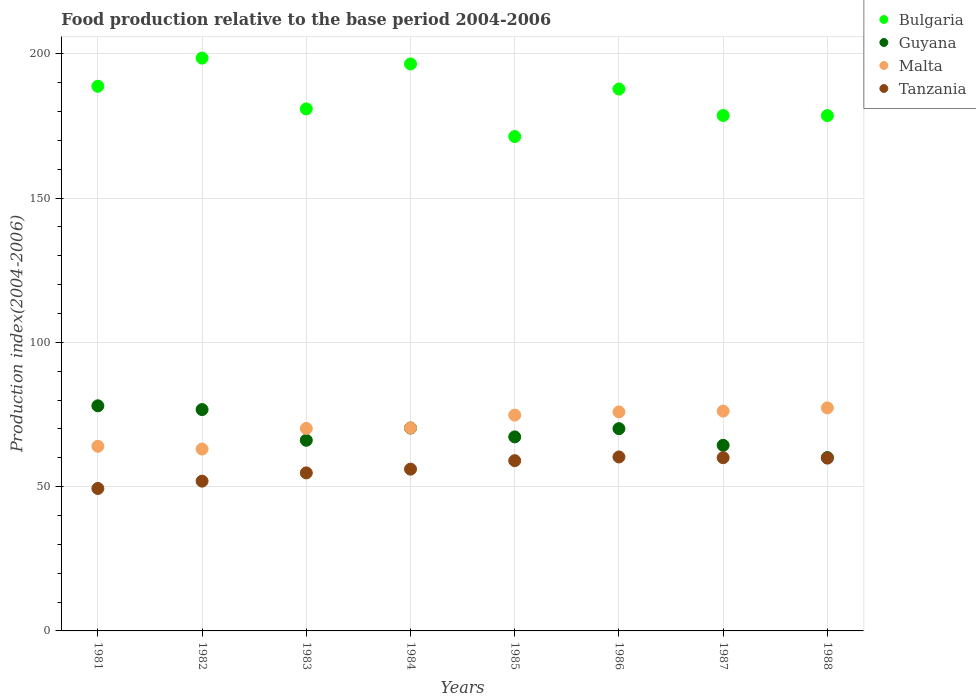How many different coloured dotlines are there?
Make the answer very short. 4. Is the number of dotlines equal to the number of legend labels?
Provide a short and direct response. Yes. What is the food production index in Malta in 1983?
Make the answer very short. 70.17. Across all years, what is the maximum food production index in Guyana?
Keep it short and to the point. 78.02. Across all years, what is the minimum food production index in Guyana?
Give a very brief answer. 60.08. What is the total food production index in Bulgaria in the graph?
Provide a succinct answer. 1481.03. What is the difference between the food production index in Malta in 1981 and that in 1987?
Your response must be concise. -12.19. What is the difference between the food production index in Guyana in 1981 and the food production index in Malta in 1987?
Ensure brevity in your answer.  1.84. What is the average food production index in Guyana per year?
Your answer should be compact. 69.11. In the year 1982, what is the difference between the food production index in Tanzania and food production index in Bulgaria?
Provide a short and direct response. -146.61. What is the ratio of the food production index in Guyana in 1984 to that in 1988?
Make the answer very short. 1.17. Is the difference between the food production index in Tanzania in 1981 and 1982 greater than the difference between the food production index in Bulgaria in 1981 and 1982?
Provide a short and direct response. Yes. What is the difference between the highest and the second highest food production index in Tanzania?
Your answer should be very brief. 0.26. What is the difference between the highest and the lowest food production index in Bulgaria?
Offer a very short reply. 27.19. Is the sum of the food production index in Malta in 1982 and 1986 greater than the maximum food production index in Guyana across all years?
Ensure brevity in your answer.  Yes. Is it the case that in every year, the sum of the food production index in Tanzania and food production index in Malta  is greater than the food production index in Bulgaria?
Give a very brief answer. No. Does the food production index in Bulgaria monotonically increase over the years?
Offer a terse response. No. Is the food production index in Bulgaria strictly greater than the food production index in Guyana over the years?
Provide a succinct answer. Yes. Is the food production index in Guyana strictly less than the food production index in Bulgaria over the years?
Provide a succinct answer. Yes. How many dotlines are there?
Your answer should be compact. 4. How many years are there in the graph?
Keep it short and to the point. 8. Are the values on the major ticks of Y-axis written in scientific E-notation?
Your response must be concise. No. Does the graph contain grids?
Offer a terse response. Yes. Where does the legend appear in the graph?
Give a very brief answer. Top right. What is the title of the graph?
Offer a terse response. Food production relative to the base period 2004-2006. Does "Tunisia" appear as one of the legend labels in the graph?
Provide a succinct answer. No. What is the label or title of the X-axis?
Offer a terse response. Years. What is the label or title of the Y-axis?
Provide a short and direct response. Production index(2004-2006). What is the Production index(2004-2006) of Bulgaria in 1981?
Provide a short and direct response. 188.76. What is the Production index(2004-2006) of Guyana in 1981?
Your answer should be compact. 78.02. What is the Production index(2004-2006) in Malta in 1981?
Offer a very short reply. 63.99. What is the Production index(2004-2006) of Tanzania in 1981?
Your answer should be compact. 49.37. What is the Production index(2004-2006) of Bulgaria in 1982?
Offer a terse response. 198.52. What is the Production index(2004-2006) of Guyana in 1982?
Your response must be concise. 76.71. What is the Production index(2004-2006) in Malta in 1982?
Your answer should be very brief. 63.03. What is the Production index(2004-2006) of Tanzania in 1982?
Offer a terse response. 51.91. What is the Production index(2004-2006) in Bulgaria in 1983?
Your answer should be very brief. 180.91. What is the Production index(2004-2006) in Guyana in 1983?
Make the answer very short. 66.07. What is the Production index(2004-2006) of Malta in 1983?
Your answer should be very brief. 70.17. What is the Production index(2004-2006) in Tanzania in 1983?
Your answer should be very brief. 54.77. What is the Production index(2004-2006) of Bulgaria in 1984?
Offer a terse response. 196.49. What is the Production index(2004-2006) in Guyana in 1984?
Offer a terse response. 70.31. What is the Production index(2004-2006) in Malta in 1984?
Provide a succinct answer. 70.35. What is the Production index(2004-2006) of Tanzania in 1984?
Your answer should be very brief. 56.07. What is the Production index(2004-2006) of Bulgaria in 1985?
Your answer should be compact. 171.33. What is the Production index(2004-2006) in Guyana in 1985?
Give a very brief answer. 67.24. What is the Production index(2004-2006) of Malta in 1985?
Offer a terse response. 74.79. What is the Production index(2004-2006) of Tanzania in 1985?
Your response must be concise. 59.01. What is the Production index(2004-2006) in Bulgaria in 1986?
Make the answer very short. 187.8. What is the Production index(2004-2006) in Guyana in 1986?
Your answer should be very brief. 70.1. What is the Production index(2004-2006) of Malta in 1986?
Provide a succinct answer. 75.89. What is the Production index(2004-2006) of Tanzania in 1986?
Ensure brevity in your answer.  60.29. What is the Production index(2004-2006) in Bulgaria in 1987?
Give a very brief answer. 178.63. What is the Production index(2004-2006) of Guyana in 1987?
Offer a terse response. 64.32. What is the Production index(2004-2006) in Malta in 1987?
Ensure brevity in your answer.  76.18. What is the Production index(2004-2006) of Tanzania in 1987?
Your answer should be compact. 60.03. What is the Production index(2004-2006) in Bulgaria in 1988?
Ensure brevity in your answer.  178.59. What is the Production index(2004-2006) of Guyana in 1988?
Offer a terse response. 60.08. What is the Production index(2004-2006) in Malta in 1988?
Keep it short and to the point. 77.3. What is the Production index(2004-2006) of Tanzania in 1988?
Give a very brief answer. 59.89. Across all years, what is the maximum Production index(2004-2006) in Bulgaria?
Your response must be concise. 198.52. Across all years, what is the maximum Production index(2004-2006) in Guyana?
Your response must be concise. 78.02. Across all years, what is the maximum Production index(2004-2006) in Malta?
Your answer should be compact. 77.3. Across all years, what is the maximum Production index(2004-2006) of Tanzania?
Give a very brief answer. 60.29. Across all years, what is the minimum Production index(2004-2006) in Bulgaria?
Provide a short and direct response. 171.33. Across all years, what is the minimum Production index(2004-2006) in Guyana?
Give a very brief answer. 60.08. Across all years, what is the minimum Production index(2004-2006) in Malta?
Give a very brief answer. 63.03. Across all years, what is the minimum Production index(2004-2006) in Tanzania?
Make the answer very short. 49.37. What is the total Production index(2004-2006) of Bulgaria in the graph?
Offer a very short reply. 1481.03. What is the total Production index(2004-2006) in Guyana in the graph?
Provide a short and direct response. 552.85. What is the total Production index(2004-2006) in Malta in the graph?
Provide a short and direct response. 571.7. What is the total Production index(2004-2006) of Tanzania in the graph?
Make the answer very short. 451.34. What is the difference between the Production index(2004-2006) of Bulgaria in 1981 and that in 1982?
Your answer should be compact. -9.76. What is the difference between the Production index(2004-2006) in Guyana in 1981 and that in 1982?
Your response must be concise. 1.31. What is the difference between the Production index(2004-2006) of Malta in 1981 and that in 1982?
Your answer should be very brief. 0.96. What is the difference between the Production index(2004-2006) in Tanzania in 1981 and that in 1982?
Keep it short and to the point. -2.54. What is the difference between the Production index(2004-2006) in Bulgaria in 1981 and that in 1983?
Give a very brief answer. 7.85. What is the difference between the Production index(2004-2006) of Guyana in 1981 and that in 1983?
Your response must be concise. 11.95. What is the difference between the Production index(2004-2006) of Malta in 1981 and that in 1983?
Make the answer very short. -6.18. What is the difference between the Production index(2004-2006) in Tanzania in 1981 and that in 1983?
Ensure brevity in your answer.  -5.4. What is the difference between the Production index(2004-2006) of Bulgaria in 1981 and that in 1984?
Provide a succinct answer. -7.73. What is the difference between the Production index(2004-2006) of Guyana in 1981 and that in 1984?
Give a very brief answer. 7.71. What is the difference between the Production index(2004-2006) in Malta in 1981 and that in 1984?
Your answer should be compact. -6.36. What is the difference between the Production index(2004-2006) in Bulgaria in 1981 and that in 1985?
Provide a succinct answer. 17.43. What is the difference between the Production index(2004-2006) in Guyana in 1981 and that in 1985?
Make the answer very short. 10.78. What is the difference between the Production index(2004-2006) in Malta in 1981 and that in 1985?
Offer a terse response. -10.8. What is the difference between the Production index(2004-2006) in Tanzania in 1981 and that in 1985?
Your response must be concise. -9.64. What is the difference between the Production index(2004-2006) in Bulgaria in 1981 and that in 1986?
Provide a short and direct response. 0.96. What is the difference between the Production index(2004-2006) in Guyana in 1981 and that in 1986?
Give a very brief answer. 7.92. What is the difference between the Production index(2004-2006) of Malta in 1981 and that in 1986?
Ensure brevity in your answer.  -11.9. What is the difference between the Production index(2004-2006) of Tanzania in 1981 and that in 1986?
Your answer should be very brief. -10.92. What is the difference between the Production index(2004-2006) in Bulgaria in 1981 and that in 1987?
Ensure brevity in your answer.  10.13. What is the difference between the Production index(2004-2006) in Guyana in 1981 and that in 1987?
Ensure brevity in your answer.  13.7. What is the difference between the Production index(2004-2006) of Malta in 1981 and that in 1987?
Your response must be concise. -12.19. What is the difference between the Production index(2004-2006) in Tanzania in 1981 and that in 1987?
Your answer should be compact. -10.66. What is the difference between the Production index(2004-2006) in Bulgaria in 1981 and that in 1988?
Offer a very short reply. 10.17. What is the difference between the Production index(2004-2006) in Guyana in 1981 and that in 1988?
Provide a succinct answer. 17.94. What is the difference between the Production index(2004-2006) of Malta in 1981 and that in 1988?
Your response must be concise. -13.31. What is the difference between the Production index(2004-2006) of Tanzania in 1981 and that in 1988?
Your answer should be very brief. -10.52. What is the difference between the Production index(2004-2006) in Bulgaria in 1982 and that in 1983?
Keep it short and to the point. 17.61. What is the difference between the Production index(2004-2006) in Guyana in 1982 and that in 1983?
Give a very brief answer. 10.64. What is the difference between the Production index(2004-2006) of Malta in 1982 and that in 1983?
Ensure brevity in your answer.  -7.14. What is the difference between the Production index(2004-2006) of Tanzania in 1982 and that in 1983?
Offer a very short reply. -2.86. What is the difference between the Production index(2004-2006) of Bulgaria in 1982 and that in 1984?
Make the answer very short. 2.03. What is the difference between the Production index(2004-2006) of Malta in 1982 and that in 1984?
Keep it short and to the point. -7.32. What is the difference between the Production index(2004-2006) of Tanzania in 1982 and that in 1984?
Ensure brevity in your answer.  -4.16. What is the difference between the Production index(2004-2006) in Bulgaria in 1982 and that in 1985?
Keep it short and to the point. 27.19. What is the difference between the Production index(2004-2006) of Guyana in 1982 and that in 1985?
Offer a very short reply. 9.47. What is the difference between the Production index(2004-2006) of Malta in 1982 and that in 1985?
Give a very brief answer. -11.76. What is the difference between the Production index(2004-2006) of Bulgaria in 1982 and that in 1986?
Provide a short and direct response. 10.72. What is the difference between the Production index(2004-2006) in Guyana in 1982 and that in 1986?
Give a very brief answer. 6.61. What is the difference between the Production index(2004-2006) in Malta in 1982 and that in 1986?
Provide a succinct answer. -12.86. What is the difference between the Production index(2004-2006) of Tanzania in 1982 and that in 1986?
Offer a terse response. -8.38. What is the difference between the Production index(2004-2006) of Bulgaria in 1982 and that in 1987?
Provide a short and direct response. 19.89. What is the difference between the Production index(2004-2006) of Guyana in 1982 and that in 1987?
Ensure brevity in your answer.  12.39. What is the difference between the Production index(2004-2006) in Malta in 1982 and that in 1987?
Offer a very short reply. -13.15. What is the difference between the Production index(2004-2006) in Tanzania in 1982 and that in 1987?
Provide a succinct answer. -8.12. What is the difference between the Production index(2004-2006) in Bulgaria in 1982 and that in 1988?
Ensure brevity in your answer.  19.93. What is the difference between the Production index(2004-2006) in Guyana in 1982 and that in 1988?
Offer a very short reply. 16.63. What is the difference between the Production index(2004-2006) of Malta in 1982 and that in 1988?
Provide a short and direct response. -14.27. What is the difference between the Production index(2004-2006) of Tanzania in 1982 and that in 1988?
Provide a succinct answer. -7.98. What is the difference between the Production index(2004-2006) of Bulgaria in 1983 and that in 1984?
Offer a terse response. -15.58. What is the difference between the Production index(2004-2006) in Guyana in 1983 and that in 1984?
Provide a short and direct response. -4.24. What is the difference between the Production index(2004-2006) of Malta in 1983 and that in 1984?
Keep it short and to the point. -0.18. What is the difference between the Production index(2004-2006) in Tanzania in 1983 and that in 1984?
Your answer should be very brief. -1.3. What is the difference between the Production index(2004-2006) of Bulgaria in 1983 and that in 1985?
Your answer should be compact. 9.58. What is the difference between the Production index(2004-2006) in Guyana in 1983 and that in 1985?
Your response must be concise. -1.17. What is the difference between the Production index(2004-2006) in Malta in 1983 and that in 1985?
Provide a succinct answer. -4.62. What is the difference between the Production index(2004-2006) in Tanzania in 1983 and that in 1985?
Your answer should be compact. -4.24. What is the difference between the Production index(2004-2006) of Bulgaria in 1983 and that in 1986?
Offer a terse response. -6.89. What is the difference between the Production index(2004-2006) of Guyana in 1983 and that in 1986?
Your answer should be very brief. -4.03. What is the difference between the Production index(2004-2006) of Malta in 1983 and that in 1986?
Provide a short and direct response. -5.72. What is the difference between the Production index(2004-2006) in Tanzania in 1983 and that in 1986?
Make the answer very short. -5.52. What is the difference between the Production index(2004-2006) in Bulgaria in 1983 and that in 1987?
Your answer should be compact. 2.28. What is the difference between the Production index(2004-2006) in Malta in 1983 and that in 1987?
Provide a short and direct response. -6.01. What is the difference between the Production index(2004-2006) of Tanzania in 1983 and that in 1987?
Give a very brief answer. -5.26. What is the difference between the Production index(2004-2006) in Bulgaria in 1983 and that in 1988?
Ensure brevity in your answer.  2.32. What is the difference between the Production index(2004-2006) in Guyana in 1983 and that in 1988?
Ensure brevity in your answer.  5.99. What is the difference between the Production index(2004-2006) of Malta in 1983 and that in 1988?
Offer a terse response. -7.13. What is the difference between the Production index(2004-2006) of Tanzania in 1983 and that in 1988?
Your answer should be compact. -5.12. What is the difference between the Production index(2004-2006) of Bulgaria in 1984 and that in 1985?
Ensure brevity in your answer.  25.16. What is the difference between the Production index(2004-2006) of Guyana in 1984 and that in 1985?
Your response must be concise. 3.07. What is the difference between the Production index(2004-2006) in Malta in 1984 and that in 1985?
Your answer should be compact. -4.44. What is the difference between the Production index(2004-2006) of Tanzania in 1984 and that in 1985?
Ensure brevity in your answer.  -2.94. What is the difference between the Production index(2004-2006) of Bulgaria in 1984 and that in 1986?
Ensure brevity in your answer.  8.69. What is the difference between the Production index(2004-2006) in Guyana in 1984 and that in 1986?
Provide a succinct answer. 0.21. What is the difference between the Production index(2004-2006) of Malta in 1984 and that in 1986?
Make the answer very short. -5.54. What is the difference between the Production index(2004-2006) in Tanzania in 1984 and that in 1986?
Provide a succinct answer. -4.22. What is the difference between the Production index(2004-2006) in Bulgaria in 1984 and that in 1987?
Make the answer very short. 17.86. What is the difference between the Production index(2004-2006) of Guyana in 1984 and that in 1987?
Make the answer very short. 5.99. What is the difference between the Production index(2004-2006) in Malta in 1984 and that in 1987?
Your answer should be very brief. -5.83. What is the difference between the Production index(2004-2006) in Tanzania in 1984 and that in 1987?
Provide a short and direct response. -3.96. What is the difference between the Production index(2004-2006) in Bulgaria in 1984 and that in 1988?
Offer a very short reply. 17.9. What is the difference between the Production index(2004-2006) of Guyana in 1984 and that in 1988?
Ensure brevity in your answer.  10.23. What is the difference between the Production index(2004-2006) of Malta in 1984 and that in 1988?
Ensure brevity in your answer.  -6.95. What is the difference between the Production index(2004-2006) in Tanzania in 1984 and that in 1988?
Offer a very short reply. -3.82. What is the difference between the Production index(2004-2006) of Bulgaria in 1985 and that in 1986?
Your response must be concise. -16.47. What is the difference between the Production index(2004-2006) in Guyana in 1985 and that in 1986?
Provide a short and direct response. -2.86. What is the difference between the Production index(2004-2006) in Malta in 1985 and that in 1986?
Offer a terse response. -1.1. What is the difference between the Production index(2004-2006) of Tanzania in 1985 and that in 1986?
Make the answer very short. -1.28. What is the difference between the Production index(2004-2006) of Bulgaria in 1985 and that in 1987?
Give a very brief answer. -7.3. What is the difference between the Production index(2004-2006) of Guyana in 1985 and that in 1987?
Your answer should be very brief. 2.92. What is the difference between the Production index(2004-2006) of Malta in 1985 and that in 1987?
Ensure brevity in your answer.  -1.39. What is the difference between the Production index(2004-2006) in Tanzania in 1985 and that in 1987?
Provide a succinct answer. -1.02. What is the difference between the Production index(2004-2006) in Bulgaria in 1985 and that in 1988?
Provide a succinct answer. -7.26. What is the difference between the Production index(2004-2006) in Guyana in 1985 and that in 1988?
Your answer should be very brief. 7.16. What is the difference between the Production index(2004-2006) of Malta in 1985 and that in 1988?
Provide a short and direct response. -2.51. What is the difference between the Production index(2004-2006) in Tanzania in 1985 and that in 1988?
Offer a very short reply. -0.88. What is the difference between the Production index(2004-2006) in Bulgaria in 1986 and that in 1987?
Your answer should be very brief. 9.17. What is the difference between the Production index(2004-2006) in Guyana in 1986 and that in 1987?
Provide a succinct answer. 5.78. What is the difference between the Production index(2004-2006) of Malta in 1986 and that in 1987?
Give a very brief answer. -0.29. What is the difference between the Production index(2004-2006) of Tanzania in 1986 and that in 1987?
Your answer should be compact. 0.26. What is the difference between the Production index(2004-2006) of Bulgaria in 1986 and that in 1988?
Make the answer very short. 9.21. What is the difference between the Production index(2004-2006) of Guyana in 1986 and that in 1988?
Your response must be concise. 10.02. What is the difference between the Production index(2004-2006) of Malta in 1986 and that in 1988?
Make the answer very short. -1.41. What is the difference between the Production index(2004-2006) of Guyana in 1987 and that in 1988?
Provide a short and direct response. 4.24. What is the difference between the Production index(2004-2006) in Malta in 1987 and that in 1988?
Offer a very short reply. -1.12. What is the difference between the Production index(2004-2006) in Tanzania in 1987 and that in 1988?
Offer a very short reply. 0.14. What is the difference between the Production index(2004-2006) in Bulgaria in 1981 and the Production index(2004-2006) in Guyana in 1982?
Make the answer very short. 112.05. What is the difference between the Production index(2004-2006) of Bulgaria in 1981 and the Production index(2004-2006) of Malta in 1982?
Keep it short and to the point. 125.73. What is the difference between the Production index(2004-2006) in Bulgaria in 1981 and the Production index(2004-2006) in Tanzania in 1982?
Offer a very short reply. 136.85. What is the difference between the Production index(2004-2006) of Guyana in 1981 and the Production index(2004-2006) of Malta in 1982?
Make the answer very short. 14.99. What is the difference between the Production index(2004-2006) in Guyana in 1981 and the Production index(2004-2006) in Tanzania in 1982?
Provide a succinct answer. 26.11. What is the difference between the Production index(2004-2006) in Malta in 1981 and the Production index(2004-2006) in Tanzania in 1982?
Provide a short and direct response. 12.08. What is the difference between the Production index(2004-2006) in Bulgaria in 1981 and the Production index(2004-2006) in Guyana in 1983?
Keep it short and to the point. 122.69. What is the difference between the Production index(2004-2006) in Bulgaria in 1981 and the Production index(2004-2006) in Malta in 1983?
Your answer should be very brief. 118.59. What is the difference between the Production index(2004-2006) of Bulgaria in 1981 and the Production index(2004-2006) of Tanzania in 1983?
Your answer should be very brief. 133.99. What is the difference between the Production index(2004-2006) of Guyana in 1981 and the Production index(2004-2006) of Malta in 1983?
Your answer should be very brief. 7.85. What is the difference between the Production index(2004-2006) in Guyana in 1981 and the Production index(2004-2006) in Tanzania in 1983?
Provide a short and direct response. 23.25. What is the difference between the Production index(2004-2006) in Malta in 1981 and the Production index(2004-2006) in Tanzania in 1983?
Make the answer very short. 9.22. What is the difference between the Production index(2004-2006) of Bulgaria in 1981 and the Production index(2004-2006) of Guyana in 1984?
Offer a terse response. 118.45. What is the difference between the Production index(2004-2006) in Bulgaria in 1981 and the Production index(2004-2006) in Malta in 1984?
Offer a terse response. 118.41. What is the difference between the Production index(2004-2006) of Bulgaria in 1981 and the Production index(2004-2006) of Tanzania in 1984?
Keep it short and to the point. 132.69. What is the difference between the Production index(2004-2006) of Guyana in 1981 and the Production index(2004-2006) of Malta in 1984?
Offer a terse response. 7.67. What is the difference between the Production index(2004-2006) of Guyana in 1981 and the Production index(2004-2006) of Tanzania in 1984?
Provide a short and direct response. 21.95. What is the difference between the Production index(2004-2006) of Malta in 1981 and the Production index(2004-2006) of Tanzania in 1984?
Make the answer very short. 7.92. What is the difference between the Production index(2004-2006) in Bulgaria in 1981 and the Production index(2004-2006) in Guyana in 1985?
Give a very brief answer. 121.52. What is the difference between the Production index(2004-2006) of Bulgaria in 1981 and the Production index(2004-2006) of Malta in 1985?
Provide a short and direct response. 113.97. What is the difference between the Production index(2004-2006) in Bulgaria in 1981 and the Production index(2004-2006) in Tanzania in 1985?
Ensure brevity in your answer.  129.75. What is the difference between the Production index(2004-2006) in Guyana in 1981 and the Production index(2004-2006) in Malta in 1985?
Provide a short and direct response. 3.23. What is the difference between the Production index(2004-2006) of Guyana in 1981 and the Production index(2004-2006) of Tanzania in 1985?
Your response must be concise. 19.01. What is the difference between the Production index(2004-2006) of Malta in 1981 and the Production index(2004-2006) of Tanzania in 1985?
Your response must be concise. 4.98. What is the difference between the Production index(2004-2006) in Bulgaria in 1981 and the Production index(2004-2006) in Guyana in 1986?
Ensure brevity in your answer.  118.66. What is the difference between the Production index(2004-2006) in Bulgaria in 1981 and the Production index(2004-2006) in Malta in 1986?
Offer a very short reply. 112.87. What is the difference between the Production index(2004-2006) of Bulgaria in 1981 and the Production index(2004-2006) of Tanzania in 1986?
Offer a terse response. 128.47. What is the difference between the Production index(2004-2006) in Guyana in 1981 and the Production index(2004-2006) in Malta in 1986?
Give a very brief answer. 2.13. What is the difference between the Production index(2004-2006) in Guyana in 1981 and the Production index(2004-2006) in Tanzania in 1986?
Make the answer very short. 17.73. What is the difference between the Production index(2004-2006) of Bulgaria in 1981 and the Production index(2004-2006) of Guyana in 1987?
Provide a short and direct response. 124.44. What is the difference between the Production index(2004-2006) of Bulgaria in 1981 and the Production index(2004-2006) of Malta in 1987?
Keep it short and to the point. 112.58. What is the difference between the Production index(2004-2006) in Bulgaria in 1981 and the Production index(2004-2006) in Tanzania in 1987?
Keep it short and to the point. 128.73. What is the difference between the Production index(2004-2006) in Guyana in 1981 and the Production index(2004-2006) in Malta in 1987?
Give a very brief answer. 1.84. What is the difference between the Production index(2004-2006) of Guyana in 1981 and the Production index(2004-2006) of Tanzania in 1987?
Your response must be concise. 17.99. What is the difference between the Production index(2004-2006) of Malta in 1981 and the Production index(2004-2006) of Tanzania in 1987?
Keep it short and to the point. 3.96. What is the difference between the Production index(2004-2006) of Bulgaria in 1981 and the Production index(2004-2006) of Guyana in 1988?
Provide a succinct answer. 128.68. What is the difference between the Production index(2004-2006) of Bulgaria in 1981 and the Production index(2004-2006) of Malta in 1988?
Provide a succinct answer. 111.46. What is the difference between the Production index(2004-2006) of Bulgaria in 1981 and the Production index(2004-2006) of Tanzania in 1988?
Your answer should be compact. 128.87. What is the difference between the Production index(2004-2006) in Guyana in 1981 and the Production index(2004-2006) in Malta in 1988?
Provide a short and direct response. 0.72. What is the difference between the Production index(2004-2006) in Guyana in 1981 and the Production index(2004-2006) in Tanzania in 1988?
Ensure brevity in your answer.  18.13. What is the difference between the Production index(2004-2006) of Malta in 1981 and the Production index(2004-2006) of Tanzania in 1988?
Your answer should be very brief. 4.1. What is the difference between the Production index(2004-2006) of Bulgaria in 1982 and the Production index(2004-2006) of Guyana in 1983?
Offer a very short reply. 132.45. What is the difference between the Production index(2004-2006) of Bulgaria in 1982 and the Production index(2004-2006) of Malta in 1983?
Offer a very short reply. 128.35. What is the difference between the Production index(2004-2006) of Bulgaria in 1982 and the Production index(2004-2006) of Tanzania in 1983?
Offer a terse response. 143.75. What is the difference between the Production index(2004-2006) in Guyana in 1982 and the Production index(2004-2006) in Malta in 1983?
Offer a terse response. 6.54. What is the difference between the Production index(2004-2006) in Guyana in 1982 and the Production index(2004-2006) in Tanzania in 1983?
Provide a short and direct response. 21.94. What is the difference between the Production index(2004-2006) in Malta in 1982 and the Production index(2004-2006) in Tanzania in 1983?
Offer a terse response. 8.26. What is the difference between the Production index(2004-2006) of Bulgaria in 1982 and the Production index(2004-2006) of Guyana in 1984?
Ensure brevity in your answer.  128.21. What is the difference between the Production index(2004-2006) in Bulgaria in 1982 and the Production index(2004-2006) in Malta in 1984?
Offer a terse response. 128.17. What is the difference between the Production index(2004-2006) in Bulgaria in 1982 and the Production index(2004-2006) in Tanzania in 1984?
Provide a short and direct response. 142.45. What is the difference between the Production index(2004-2006) of Guyana in 1982 and the Production index(2004-2006) of Malta in 1984?
Keep it short and to the point. 6.36. What is the difference between the Production index(2004-2006) in Guyana in 1982 and the Production index(2004-2006) in Tanzania in 1984?
Your answer should be compact. 20.64. What is the difference between the Production index(2004-2006) of Malta in 1982 and the Production index(2004-2006) of Tanzania in 1984?
Offer a very short reply. 6.96. What is the difference between the Production index(2004-2006) in Bulgaria in 1982 and the Production index(2004-2006) in Guyana in 1985?
Keep it short and to the point. 131.28. What is the difference between the Production index(2004-2006) in Bulgaria in 1982 and the Production index(2004-2006) in Malta in 1985?
Offer a very short reply. 123.73. What is the difference between the Production index(2004-2006) of Bulgaria in 1982 and the Production index(2004-2006) of Tanzania in 1985?
Your answer should be compact. 139.51. What is the difference between the Production index(2004-2006) in Guyana in 1982 and the Production index(2004-2006) in Malta in 1985?
Give a very brief answer. 1.92. What is the difference between the Production index(2004-2006) of Malta in 1982 and the Production index(2004-2006) of Tanzania in 1985?
Your response must be concise. 4.02. What is the difference between the Production index(2004-2006) of Bulgaria in 1982 and the Production index(2004-2006) of Guyana in 1986?
Make the answer very short. 128.42. What is the difference between the Production index(2004-2006) in Bulgaria in 1982 and the Production index(2004-2006) in Malta in 1986?
Your response must be concise. 122.63. What is the difference between the Production index(2004-2006) of Bulgaria in 1982 and the Production index(2004-2006) of Tanzania in 1986?
Your answer should be very brief. 138.23. What is the difference between the Production index(2004-2006) of Guyana in 1982 and the Production index(2004-2006) of Malta in 1986?
Your answer should be compact. 0.82. What is the difference between the Production index(2004-2006) of Guyana in 1982 and the Production index(2004-2006) of Tanzania in 1986?
Make the answer very short. 16.42. What is the difference between the Production index(2004-2006) in Malta in 1982 and the Production index(2004-2006) in Tanzania in 1986?
Make the answer very short. 2.74. What is the difference between the Production index(2004-2006) in Bulgaria in 1982 and the Production index(2004-2006) in Guyana in 1987?
Offer a terse response. 134.2. What is the difference between the Production index(2004-2006) of Bulgaria in 1982 and the Production index(2004-2006) of Malta in 1987?
Offer a very short reply. 122.34. What is the difference between the Production index(2004-2006) of Bulgaria in 1982 and the Production index(2004-2006) of Tanzania in 1987?
Keep it short and to the point. 138.49. What is the difference between the Production index(2004-2006) of Guyana in 1982 and the Production index(2004-2006) of Malta in 1987?
Provide a succinct answer. 0.53. What is the difference between the Production index(2004-2006) in Guyana in 1982 and the Production index(2004-2006) in Tanzania in 1987?
Keep it short and to the point. 16.68. What is the difference between the Production index(2004-2006) in Bulgaria in 1982 and the Production index(2004-2006) in Guyana in 1988?
Your answer should be very brief. 138.44. What is the difference between the Production index(2004-2006) in Bulgaria in 1982 and the Production index(2004-2006) in Malta in 1988?
Offer a very short reply. 121.22. What is the difference between the Production index(2004-2006) of Bulgaria in 1982 and the Production index(2004-2006) of Tanzania in 1988?
Your answer should be very brief. 138.63. What is the difference between the Production index(2004-2006) of Guyana in 1982 and the Production index(2004-2006) of Malta in 1988?
Give a very brief answer. -0.59. What is the difference between the Production index(2004-2006) of Guyana in 1982 and the Production index(2004-2006) of Tanzania in 1988?
Offer a terse response. 16.82. What is the difference between the Production index(2004-2006) in Malta in 1982 and the Production index(2004-2006) in Tanzania in 1988?
Give a very brief answer. 3.14. What is the difference between the Production index(2004-2006) in Bulgaria in 1983 and the Production index(2004-2006) in Guyana in 1984?
Offer a very short reply. 110.6. What is the difference between the Production index(2004-2006) in Bulgaria in 1983 and the Production index(2004-2006) in Malta in 1984?
Offer a very short reply. 110.56. What is the difference between the Production index(2004-2006) in Bulgaria in 1983 and the Production index(2004-2006) in Tanzania in 1984?
Offer a terse response. 124.84. What is the difference between the Production index(2004-2006) in Guyana in 1983 and the Production index(2004-2006) in Malta in 1984?
Your answer should be compact. -4.28. What is the difference between the Production index(2004-2006) of Guyana in 1983 and the Production index(2004-2006) of Tanzania in 1984?
Offer a terse response. 10. What is the difference between the Production index(2004-2006) in Bulgaria in 1983 and the Production index(2004-2006) in Guyana in 1985?
Provide a succinct answer. 113.67. What is the difference between the Production index(2004-2006) of Bulgaria in 1983 and the Production index(2004-2006) of Malta in 1985?
Ensure brevity in your answer.  106.12. What is the difference between the Production index(2004-2006) of Bulgaria in 1983 and the Production index(2004-2006) of Tanzania in 1985?
Provide a short and direct response. 121.9. What is the difference between the Production index(2004-2006) in Guyana in 1983 and the Production index(2004-2006) in Malta in 1985?
Make the answer very short. -8.72. What is the difference between the Production index(2004-2006) of Guyana in 1983 and the Production index(2004-2006) of Tanzania in 1985?
Give a very brief answer. 7.06. What is the difference between the Production index(2004-2006) of Malta in 1983 and the Production index(2004-2006) of Tanzania in 1985?
Give a very brief answer. 11.16. What is the difference between the Production index(2004-2006) of Bulgaria in 1983 and the Production index(2004-2006) of Guyana in 1986?
Your answer should be very brief. 110.81. What is the difference between the Production index(2004-2006) in Bulgaria in 1983 and the Production index(2004-2006) in Malta in 1986?
Provide a succinct answer. 105.02. What is the difference between the Production index(2004-2006) of Bulgaria in 1983 and the Production index(2004-2006) of Tanzania in 1986?
Your response must be concise. 120.62. What is the difference between the Production index(2004-2006) in Guyana in 1983 and the Production index(2004-2006) in Malta in 1986?
Provide a succinct answer. -9.82. What is the difference between the Production index(2004-2006) of Guyana in 1983 and the Production index(2004-2006) of Tanzania in 1986?
Your response must be concise. 5.78. What is the difference between the Production index(2004-2006) in Malta in 1983 and the Production index(2004-2006) in Tanzania in 1986?
Your response must be concise. 9.88. What is the difference between the Production index(2004-2006) of Bulgaria in 1983 and the Production index(2004-2006) of Guyana in 1987?
Your response must be concise. 116.59. What is the difference between the Production index(2004-2006) of Bulgaria in 1983 and the Production index(2004-2006) of Malta in 1987?
Offer a terse response. 104.73. What is the difference between the Production index(2004-2006) in Bulgaria in 1983 and the Production index(2004-2006) in Tanzania in 1987?
Ensure brevity in your answer.  120.88. What is the difference between the Production index(2004-2006) of Guyana in 1983 and the Production index(2004-2006) of Malta in 1987?
Offer a very short reply. -10.11. What is the difference between the Production index(2004-2006) of Guyana in 1983 and the Production index(2004-2006) of Tanzania in 1987?
Offer a terse response. 6.04. What is the difference between the Production index(2004-2006) in Malta in 1983 and the Production index(2004-2006) in Tanzania in 1987?
Offer a very short reply. 10.14. What is the difference between the Production index(2004-2006) of Bulgaria in 1983 and the Production index(2004-2006) of Guyana in 1988?
Your answer should be very brief. 120.83. What is the difference between the Production index(2004-2006) in Bulgaria in 1983 and the Production index(2004-2006) in Malta in 1988?
Make the answer very short. 103.61. What is the difference between the Production index(2004-2006) of Bulgaria in 1983 and the Production index(2004-2006) of Tanzania in 1988?
Offer a terse response. 121.02. What is the difference between the Production index(2004-2006) of Guyana in 1983 and the Production index(2004-2006) of Malta in 1988?
Offer a terse response. -11.23. What is the difference between the Production index(2004-2006) in Guyana in 1983 and the Production index(2004-2006) in Tanzania in 1988?
Your answer should be very brief. 6.18. What is the difference between the Production index(2004-2006) in Malta in 1983 and the Production index(2004-2006) in Tanzania in 1988?
Ensure brevity in your answer.  10.28. What is the difference between the Production index(2004-2006) of Bulgaria in 1984 and the Production index(2004-2006) of Guyana in 1985?
Your response must be concise. 129.25. What is the difference between the Production index(2004-2006) of Bulgaria in 1984 and the Production index(2004-2006) of Malta in 1985?
Give a very brief answer. 121.7. What is the difference between the Production index(2004-2006) of Bulgaria in 1984 and the Production index(2004-2006) of Tanzania in 1985?
Provide a succinct answer. 137.48. What is the difference between the Production index(2004-2006) in Guyana in 1984 and the Production index(2004-2006) in Malta in 1985?
Give a very brief answer. -4.48. What is the difference between the Production index(2004-2006) of Malta in 1984 and the Production index(2004-2006) of Tanzania in 1985?
Your answer should be compact. 11.34. What is the difference between the Production index(2004-2006) of Bulgaria in 1984 and the Production index(2004-2006) of Guyana in 1986?
Your answer should be very brief. 126.39. What is the difference between the Production index(2004-2006) of Bulgaria in 1984 and the Production index(2004-2006) of Malta in 1986?
Keep it short and to the point. 120.6. What is the difference between the Production index(2004-2006) in Bulgaria in 1984 and the Production index(2004-2006) in Tanzania in 1986?
Offer a terse response. 136.2. What is the difference between the Production index(2004-2006) of Guyana in 1984 and the Production index(2004-2006) of Malta in 1986?
Your response must be concise. -5.58. What is the difference between the Production index(2004-2006) in Guyana in 1984 and the Production index(2004-2006) in Tanzania in 1986?
Give a very brief answer. 10.02. What is the difference between the Production index(2004-2006) in Malta in 1984 and the Production index(2004-2006) in Tanzania in 1986?
Provide a succinct answer. 10.06. What is the difference between the Production index(2004-2006) in Bulgaria in 1984 and the Production index(2004-2006) in Guyana in 1987?
Give a very brief answer. 132.17. What is the difference between the Production index(2004-2006) in Bulgaria in 1984 and the Production index(2004-2006) in Malta in 1987?
Ensure brevity in your answer.  120.31. What is the difference between the Production index(2004-2006) of Bulgaria in 1984 and the Production index(2004-2006) of Tanzania in 1987?
Your answer should be very brief. 136.46. What is the difference between the Production index(2004-2006) in Guyana in 1984 and the Production index(2004-2006) in Malta in 1987?
Offer a terse response. -5.87. What is the difference between the Production index(2004-2006) of Guyana in 1984 and the Production index(2004-2006) of Tanzania in 1987?
Ensure brevity in your answer.  10.28. What is the difference between the Production index(2004-2006) of Malta in 1984 and the Production index(2004-2006) of Tanzania in 1987?
Give a very brief answer. 10.32. What is the difference between the Production index(2004-2006) in Bulgaria in 1984 and the Production index(2004-2006) in Guyana in 1988?
Your answer should be very brief. 136.41. What is the difference between the Production index(2004-2006) in Bulgaria in 1984 and the Production index(2004-2006) in Malta in 1988?
Your answer should be compact. 119.19. What is the difference between the Production index(2004-2006) of Bulgaria in 1984 and the Production index(2004-2006) of Tanzania in 1988?
Provide a short and direct response. 136.6. What is the difference between the Production index(2004-2006) in Guyana in 1984 and the Production index(2004-2006) in Malta in 1988?
Your answer should be very brief. -6.99. What is the difference between the Production index(2004-2006) of Guyana in 1984 and the Production index(2004-2006) of Tanzania in 1988?
Offer a terse response. 10.42. What is the difference between the Production index(2004-2006) in Malta in 1984 and the Production index(2004-2006) in Tanzania in 1988?
Keep it short and to the point. 10.46. What is the difference between the Production index(2004-2006) in Bulgaria in 1985 and the Production index(2004-2006) in Guyana in 1986?
Keep it short and to the point. 101.23. What is the difference between the Production index(2004-2006) in Bulgaria in 1985 and the Production index(2004-2006) in Malta in 1986?
Keep it short and to the point. 95.44. What is the difference between the Production index(2004-2006) of Bulgaria in 1985 and the Production index(2004-2006) of Tanzania in 1986?
Give a very brief answer. 111.04. What is the difference between the Production index(2004-2006) in Guyana in 1985 and the Production index(2004-2006) in Malta in 1986?
Your response must be concise. -8.65. What is the difference between the Production index(2004-2006) of Guyana in 1985 and the Production index(2004-2006) of Tanzania in 1986?
Ensure brevity in your answer.  6.95. What is the difference between the Production index(2004-2006) in Bulgaria in 1985 and the Production index(2004-2006) in Guyana in 1987?
Your answer should be compact. 107.01. What is the difference between the Production index(2004-2006) of Bulgaria in 1985 and the Production index(2004-2006) of Malta in 1987?
Offer a very short reply. 95.15. What is the difference between the Production index(2004-2006) of Bulgaria in 1985 and the Production index(2004-2006) of Tanzania in 1987?
Make the answer very short. 111.3. What is the difference between the Production index(2004-2006) of Guyana in 1985 and the Production index(2004-2006) of Malta in 1987?
Your answer should be compact. -8.94. What is the difference between the Production index(2004-2006) in Guyana in 1985 and the Production index(2004-2006) in Tanzania in 1987?
Make the answer very short. 7.21. What is the difference between the Production index(2004-2006) in Malta in 1985 and the Production index(2004-2006) in Tanzania in 1987?
Your answer should be very brief. 14.76. What is the difference between the Production index(2004-2006) of Bulgaria in 1985 and the Production index(2004-2006) of Guyana in 1988?
Ensure brevity in your answer.  111.25. What is the difference between the Production index(2004-2006) of Bulgaria in 1985 and the Production index(2004-2006) of Malta in 1988?
Ensure brevity in your answer.  94.03. What is the difference between the Production index(2004-2006) in Bulgaria in 1985 and the Production index(2004-2006) in Tanzania in 1988?
Offer a terse response. 111.44. What is the difference between the Production index(2004-2006) of Guyana in 1985 and the Production index(2004-2006) of Malta in 1988?
Ensure brevity in your answer.  -10.06. What is the difference between the Production index(2004-2006) of Guyana in 1985 and the Production index(2004-2006) of Tanzania in 1988?
Provide a succinct answer. 7.35. What is the difference between the Production index(2004-2006) of Bulgaria in 1986 and the Production index(2004-2006) of Guyana in 1987?
Provide a short and direct response. 123.48. What is the difference between the Production index(2004-2006) in Bulgaria in 1986 and the Production index(2004-2006) in Malta in 1987?
Offer a very short reply. 111.62. What is the difference between the Production index(2004-2006) in Bulgaria in 1986 and the Production index(2004-2006) in Tanzania in 1987?
Your answer should be compact. 127.77. What is the difference between the Production index(2004-2006) of Guyana in 1986 and the Production index(2004-2006) of Malta in 1987?
Your answer should be compact. -6.08. What is the difference between the Production index(2004-2006) of Guyana in 1986 and the Production index(2004-2006) of Tanzania in 1987?
Give a very brief answer. 10.07. What is the difference between the Production index(2004-2006) in Malta in 1986 and the Production index(2004-2006) in Tanzania in 1987?
Provide a short and direct response. 15.86. What is the difference between the Production index(2004-2006) in Bulgaria in 1986 and the Production index(2004-2006) in Guyana in 1988?
Your answer should be compact. 127.72. What is the difference between the Production index(2004-2006) of Bulgaria in 1986 and the Production index(2004-2006) of Malta in 1988?
Your answer should be compact. 110.5. What is the difference between the Production index(2004-2006) of Bulgaria in 1986 and the Production index(2004-2006) of Tanzania in 1988?
Keep it short and to the point. 127.91. What is the difference between the Production index(2004-2006) in Guyana in 1986 and the Production index(2004-2006) in Malta in 1988?
Ensure brevity in your answer.  -7.2. What is the difference between the Production index(2004-2006) of Guyana in 1986 and the Production index(2004-2006) of Tanzania in 1988?
Provide a succinct answer. 10.21. What is the difference between the Production index(2004-2006) of Bulgaria in 1987 and the Production index(2004-2006) of Guyana in 1988?
Offer a terse response. 118.55. What is the difference between the Production index(2004-2006) of Bulgaria in 1987 and the Production index(2004-2006) of Malta in 1988?
Provide a succinct answer. 101.33. What is the difference between the Production index(2004-2006) of Bulgaria in 1987 and the Production index(2004-2006) of Tanzania in 1988?
Provide a short and direct response. 118.74. What is the difference between the Production index(2004-2006) of Guyana in 1987 and the Production index(2004-2006) of Malta in 1988?
Your answer should be compact. -12.98. What is the difference between the Production index(2004-2006) of Guyana in 1987 and the Production index(2004-2006) of Tanzania in 1988?
Your response must be concise. 4.43. What is the difference between the Production index(2004-2006) in Malta in 1987 and the Production index(2004-2006) in Tanzania in 1988?
Offer a very short reply. 16.29. What is the average Production index(2004-2006) of Bulgaria per year?
Offer a very short reply. 185.13. What is the average Production index(2004-2006) in Guyana per year?
Offer a very short reply. 69.11. What is the average Production index(2004-2006) in Malta per year?
Give a very brief answer. 71.46. What is the average Production index(2004-2006) in Tanzania per year?
Provide a short and direct response. 56.42. In the year 1981, what is the difference between the Production index(2004-2006) in Bulgaria and Production index(2004-2006) in Guyana?
Your answer should be compact. 110.74. In the year 1981, what is the difference between the Production index(2004-2006) of Bulgaria and Production index(2004-2006) of Malta?
Give a very brief answer. 124.77. In the year 1981, what is the difference between the Production index(2004-2006) in Bulgaria and Production index(2004-2006) in Tanzania?
Your response must be concise. 139.39. In the year 1981, what is the difference between the Production index(2004-2006) of Guyana and Production index(2004-2006) of Malta?
Provide a short and direct response. 14.03. In the year 1981, what is the difference between the Production index(2004-2006) of Guyana and Production index(2004-2006) of Tanzania?
Keep it short and to the point. 28.65. In the year 1981, what is the difference between the Production index(2004-2006) of Malta and Production index(2004-2006) of Tanzania?
Your response must be concise. 14.62. In the year 1982, what is the difference between the Production index(2004-2006) in Bulgaria and Production index(2004-2006) in Guyana?
Offer a terse response. 121.81. In the year 1982, what is the difference between the Production index(2004-2006) in Bulgaria and Production index(2004-2006) in Malta?
Give a very brief answer. 135.49. In the year 1982, what is the difference between the Production index(2004-2006) in Bulgaria and Production index(2004-2006) in Tanzania?
Give a very brief answer. 146.61. In the year 1982, what is the difference between the Production index(2004-2006) of Guyana and Production index(2004-2006) of Malta?
Your answer should be very brief. 13.68. In the year 1982, what is the difference between the Production index(2004-2006) of Guyana and Production index(2004-2006) of Tanzania?
Your answer should be very brief. 24.8. In the year 1982, what is the difference between the Production index(2004-2006) in Malta and Production index(2004-2006) in Tanzania?
Make the answer very short. 11.12. In the year 1983, what is the difference between the Production index(2004-2006) in Bulgaria and Production index(2004-2006) in Guyana?
Keep it short and to the point. 114.84. In the year 1983, what is the difference between the Production index(2004-2006) of Bulgaria and Production index(2004-2006) of Malta?
Ensure brevity in your answer.  110.74. In the year 1983, what is the difference between the Production index(2004-2006) of Bulgaria and Production index(2004-2006) of Tanzania?
Make the answer very short. 126.14. In the year 1983, what is the difference between the Production index(2004-2006) of Malta and Production index(2004-2006) of Tanzania?
Your answer should be compact. 15.4. In the year 1984, what is the difference between the Production index(2004-2006) in Bulgaria and Production index(2004-2006) in Guyana?
Ensure brevity in your answer.  126.18. In the year 1984, what is the difference between the Production index(2004-2006) in Bulgaria and Production index(2004-2006) in Malta?
Provide a short and direct response. 126.14. In the year 1984, what is the difference between the Production index(2004-2006) in Bulgaria and Production index(2004-2006) in Tanzania?
Keep it short and to the point. 140.42. In the year 1984, what is the difference between the Production index(2004-2006) of Guyana and Production index(2004-2006) of Malta?
Give a very brief answer. -0.04. In the year 1984, what is the difference between the Production index(2004-2006) of Guyana and Production index(2004-2006) of Tanzania?
Offer a terse response. 14.24. In the year 1984, what is the difference between the Production index(2004-2006) in Malta and Production index(2004-2006) in Tanzania?
Make the answer very short. 14.28. In the year 1985, what is the difference between the Production index(2004-2006) in Bulgaria and Production index(2004-2006) in Guyana?
Provide a succinct answer. 104.09. In the year 1985, what is the difference between the Production index(2004-2006) of Bulgaria and Production index(2004-2006) of Malta?
Keep it short and to the point. 96.54. In the year 1985, what is the difference between the Production index(2004-2006) in Bulgaria and Production index(2004-2006) in Tanzania?
Offer a terse response. 112.32. In the year 1985, what is the difference between the Production index(2004-2006) of Guyana and Production index(2004-2006) of Malta?
Provide a short and direct response. -7.55. In the year 1985, what is the difference between the Production index(2004-2006) of Guyana and Production index(2004-2006) of Tanzania?
Your response must be concise. 8.23. In the year 1985, what is the difference between the Production index(2004-2006) in Malta and Production index(2004-2006) in Tanzania?
Provide a succinct answer. 15.78. In the year 1986, what is the difference between the Production index(2004-2006) of Bulgaria and Production index(2004-2006) of Guyana?
Your answer should be very brief. 117.7. In the year 1986, what is the difference between the Production index(2004-2006) of Bulgaria and Production index(2004-2006) of Malta?
Offer a terse response. 111.91. In the year 1986, what is the difference between the Production index(2004-2006) of Bulgaria and Production index(2004-2006) of Tanzania?
Give a very brief answer. 127.51. In the year 1986, what is the difference between the Production index(2004-2006) of Guyana and Production index(2004-2006) of Malta?
Offer a very short reply. -5.79. In the year 1986, what is the difference between the Production index(2004-2006) of Guyana and Production index(2004-2006) of Tanzania?
Give a very brief answer. 9.81. In the year 1987, what is the difference between the Production index(2004-2006) of Bulgaria and Production index(2004-2006) of Guyana?
Make the answer very short. 114.31. In the year 1987, what is the difference between the Production index(2004-2006) of Bulgaria and Production index(2004-2006) of Malta?
Make the answer very short. 102.45. In the year 1987, what is the difference between the Production index(2004-2006) in Bulgaria and Production index(2004-2006) in Tanzania?
Provide a short and direct response. 118.6. In the year 1987, what is the difference between the Production index(2004-2006) of Guyana and Production index(2004-2006) of Malta?
Make the answer very short. -11.86. In the year 1987, what is the difference between the Production index(2004-2006) of Guyana and Production index(2004-2006) of Tanzania?
Keep it short and to the point. 4.29. In the year 1987, what is the difference between the Production index(2004-2006) of Malta and Production index(2004-2006) of Tanzania?
Make the answer very short. 16.15. In the year 1988, what is the difference between the Production index(2004-2006) in Bulgaria and Production index(2004-2006) in Guyana?
Provide a short and direct response. 118.51. In the year 1988, what is the difference between the Production index(2004-2006) in Bulgaria and Production index(2004-2006) in Malta?
Keep it short and to the point. 101.29. In the year 1988, what is the difference between the Production index(2004-2006) in Bulgaria and Production index(2004-2006) in Tanzania?
Give a very brief answer. 118.7. In the year 1988, what is the difference between the Production index(2004-2006) in Guyana and Production index(2004-2006) in Malta?
Give a very brief answer. -17.22. In the year 1988, what is the difference between the Production index(2004-2006) in Guyana and Production index(2004-2006) in Tanzania?
Your answer should be compact. 0.19. In the year 1988, what is the difference between the Production index(2004-2006) of Malta and Production index(2004-2006) of Tanzania?
Make the answer very short. 17.41. What is the ratio of the Production index(2004-2006) in Bulgaria in 1981 to that in 1982?
Your answer should be very brief. 0.95. What is the ratio of the Production index(2004-2006) of Guyana in 1981 to that in 1982?
Offer a terse response. 1.02. What is the ratio of the Production index(2004-2006) in Malta in 1981 to that in 1982?
Offer a terse response. 1.02. What is the ratio of the Production index(2004-2006) of Tanzania in 1981 to that in 1982?
Your answer should be very brief. 0.95. What is the ratio of the Production index(2004-2006) of Bulgaria in 1981 to that in 1983?
Your answer should be very brief. 1.04. What is the ratio of the Production index(2004-2006) in Guyana in 1981 to that in 1983?
Offer a terse response. 1.18. What is the ratio of the Production index(2004-2006) of Malta in 1981 to that in 1983?
Provide a short and direct response. 0.91. What is the ratio of the Production index(2004-2006) of Tanzania in 1981 to that in 1983?
Ensure brevity in your answer.  0.9. What is the ratio of the Production index(2004-2006) of Bulgaria in 1981 to that in 1984?
Provide a succinct answer. 0.96. What is the ratio of the Production index(2004-2006) in Guyana in 1981 to that in 1984?
Keep it short and to the point. 1.11. What is the ratio of the Production index(2004-2006) of Malta in 1981 to that in 1984?
Provide a succinct answer. 0.91. What is the ratio of the Production index(2004-2006) of Tanzania in 1981 to that in 1984?
Ensure brevity in your answer.  0.88. What is the ratio of the Production index(2004-2006) of Bulgaria in 1981 to that in 1985?
Provide a succinct answer. 1.1. What is the ratio of the Production index(2004-2006) of Guyana in 1981 to that in 1985?
Your response must be concise. 1.16. What is the ratio of the Production index(2004-2006) of Malta in 1981 to that in 1985?
Offer a terse response. 0.86. What is the ratio of the Production index(2004-2006) in Tanzania in 1981 to that in 1985?
Your answer should be compact. 0.84. What is the ratio of the Production index(2004-2006) of Guyana in 1981 to that in 1986?
Provide a succinct answer. 1.11. What is the ratio of the Production index(2004-2006) in Malta in 1981 to that in 1986?
Offer a very short reply. 0.84. What is the ratio of the Production index(2004-2006) in Tanzania in 1981 to that in 1986?
Offer a very short reply. 0.82. What is the ratio of the Production index(2004-2006) of Bulgaria in 1981 to that in 1987?
Make the answer very short. 1.06. What is the ratio of the Production index(2004-2006) of Guyana in 1981 to that in 1987?
Make the answer very short. 1.21. What is the ratio of the Production index(2004-2006) in Malta in 1981 to that in 1987?
Ensure brevity in your answer.  0.84. What is the ratio of the Production index(2004-2006) of Tanzania in 1981 to that in 1987?
Your answer should be compact. 0.82. What is the ratio of the Production index(2004-2006) of Bulgaria in 1981 to that in 1988?
Provide a succinct answer. 1.06. What is the ratio of the Production index(2004-2006) in Guyana in 1981 to that in 1988?
Keep it short and to the point. 1.3. What is the ratio of the Production index(2004-2006) of Malta in 1981 to that in 1988?
Provide a short and direct response. 0.83. What is the ratio of the Production index(2004-2006) in Tanzania in 1981 to that in 1988?
Ensure brevity in your answer.  0.82. What is the ratio of the Production index(2004-2006) in Bulgaria in 1982 to that in 1983?
Ensure brevity in your answer.  1.1. What is the ratio of the Production index(2004-2006) of Guyana in 1982 to that in 1983?
Give a very brief answer. 1.16. What is the ratio of the Production index(2004-2006) in Malta in 1982 to that in 1983?
Offer a very short reply. 0.9. What is the ratio of the Production index(2004-2006) of Tanzania in 1982 to that in 1983?
Ensure brevity in your answer.  0.95. What is the ratio of the Production index(2004-2006) in Bulgaria in 1982 to that in 1984?
Your response must be concise. 1.01. What is the ratio of the Production index(2004-2006) of Guyana in 1982 to that in 1984?
Your answer should be compact. 1.09. What is the ratio of the Production index(2004-2006) in Malta in 1982 to that in 1984?
Your response must be concise. 0.9. What is the ratio of the Production index(2004-2006) of Tanzania in 1982 to that in 1984?
Your answer should be very brief. 0.93. What is the ratio of the Production index(2004-2006) of Bulgaria in 1982 to that in 1985?
Your response must be concise. 1.16. What is the ratio of the Production index(2004-2006) of Guyana in 1982 to that in 1985?
Keep it short and to the point. 1.14. What is the ratio of the Production index(2004-2006) of Malta in 1982 to that in 1985?
Your answer should be compact. 0.84. What is the ratio of the Production index(2004-2006) in Tanzania in 1982 to that in 1985?
Provide a short and direct response. 0.88. What is the ratio of the Production index(2004-2006) in Bulgaria in 1982 to that in 1986?
Give a very brief answer. 1.06. What is the ratio of the Production index(2004-2006) of Guyana in 1982 to that in 1986?
Offer a terse response. 1.09. What is the ratio of the Production index(2004-2006) of Malta in 1982 to that in 1986?
Make the answer very short. 0.83. What is the ratio of the Production index(2004-2006) of Tanzania in 1982 to that in 1986?
Give a very brief answer. 0.86. What is the ratio of the Production index(2004-2006) in Bulgaria in 1982 to that in 1987?
Offer a very short reply. 1.11. What is the ratio of the Production index(2004-2006) in Guyana in 1982 to that in 1987?
Provide a succinct answer. 1.19. What is the ratio of the Production index(2004-2006) of Malta in 1982 to that in 1987?
Your answer should be very brief. 0.83. What is the ratio of the Production index(2004-2006) of Tanzania in 1982 to that in 1987?
Ensure brevity in your answer.  0.86. What is the ratio of the Production index(2004-2006) of Bulgaria in 1982 to that in 1988?
Give a very brief answer. 1.11. What is the ratio of the Production index(2004-2006) in Guyana in 1982 to that in 1988?
Make the answer very short. 1.28. What is the ratio of the Production index(2004-2006) in Malta in 1982 to that in 1988?
Provide a short and direct response. 0.82. What is the ratio of the Production index(2004-2006) in Tanzania in 1982 to that in 1988?
Offer a terse response. 0.87. What is the ratio of the Production index(2004-2006) in Bulgaria in 1983 to that in 1984?
Offer a very short reply. 0.92. What is the ratio of the Production index(2004-2006) of Guyana in 1983 to that in 1984?
Your answer should be very brief. 0.94. What is the ratio of the Production index(2004-2006) in Malta in 1983 to that in 1984?
Your answer should be compact. 1. What is the ratio of the Production index(2004-2006) of Tanzania in 1983 to that in 1984?
Make the answer very short. 0.98. What is the ratio of the Production index(2004-2006) of Bulgaria in 1983 to that in 1985?
Your answer should be compact. 1.06. What is the ratio of the Production index(2004-2006) in Guyana in 1983 to that in 1985?
Ensure brevity in your answer.  0.98. What is the ratio of the Production index(2004-2006) of Malta in 1983 to that in 1985?
Give a very brief answer. 0.94. What is the ratio of the Production index(2004-2006) in Tanzania in 1983 to that in 1985?
Make the answer very short. 0.93. What is the ratio of the Production index(2004-2006) in Bulgaria in 1983 to that in 1986?
Make the answer very short. 0.96. What is the ratio of the Production index(2004-2006) in Guyana in 1983 to that in 1986?
Provide a short and direct response. 0.94. What is the ratio of the Production index(2004-2006) of Malta in 1983 to that in 1986?
Offer a terse response. 0.92. What is the ratio of the Production index(2004-2006) of Tanzania in 1983 to that in 1986?
Ensure brevity in your answer.  0.91. What is the ratio of the Production index(2004-2006) of Bulgaria in 1983 to that in 1987?
Offer a terse response. 1.01. What is the ratio of the Production index(2004-2006) of Guyana in 1983 to that in 1987?
Your answer should be compact. 1.03. What is the ratio of the Production index(2004-2006) of Malta in 1983 to that in 1987?
Offer a terse response. 0.92. What is the ratio of the Production index(2004-2006) of Tanzania in 1983 to that in 1987?
Your answer should be very brief. 0.91. What is the ratio of the Production index(2004-2006) of Guyana in 1983 to that in 1988?
Ensure brevity in your answer.  1.1. What is the ratio of the Production index(2004-2006) of Malta in 1983 to that in 1988?
Offer a very short reply. 0.91. What is the ratio of the Production index(2004-2006) in Tanzania in 1983 to that in 1988?
Make the answer very short. 0.91. What is the ratio of the Production index(2004-2006) of Bulgaria in 1984 to that in 1985?
Your response must be concise. 1.15. What is the ratio of the Production index(2004-2006) of Guyana in 1984 to that in 1985?
Your answer should be compact. 1.05. What is the ratio of the Production index(2004-2006) of Malta in 1984 to that in 1985?
Make the answer very short. 0.94. What is the ratio of the Production index(2004-2006) in Tanzania in 1984 to that in 1985?
Offer a very short reply. 0.95. What is the ratio of the Production index(2004-2006) of Bulgaria in 1984 to that in 1986?
Provide a succinct answer. 1.05. What is the ratio of the Production index(2004-2006) in Malta in 1984 to that in 1986?
Make the answer very short. 0.93. What is the ratio of the Production index(2004-2006) of Tanzania in 1984 to that in 1986?
Your answer should be very brief. 0.93. What is the ratio of the Production index(2004-2006) in Guyana in 1984 to that in 1987?
Your response must be concise. 1.09. What is the ratio of the Production index(2004-2006) of Malta in 1984 to that in 1987?
Make the answer very short. 0.92. What is the ratio of the Production index(2004-2006) of Tanzania in 1984 to that in 1987?
Offer a very short reply. 0.93. What is the ratio of the Production index(2004-2006) of Bulgaria in 1984 to that in 1988?
Offer a very short reply. 1.1. What is the ratio of the Production index(2004-2006) of Guyana in 1984 to that in 1988?
Your answer should be compact. 1.17. What is the ratio of the Production index(2004-2006) of Malta in 1984 to that in 1988?
Your answer should be very brief. 0.91. What is the ratio of the Production index(2004-2006) of Tanzania in 1984 to that in 1988?
Your answer should be very brief. 0.94. What is the ratio of the Production index(2004-2006) of Bulgaria in 1985 to that in 1986?
Provide a succinct answer. 0.91. What is the ratio of the Production index(2004-2006) of Guyana in 1985 to that in 1986?
Offer a very short reply. 0.96. What is the ratio of the Production index(2004-2006) in Malta in 1985 to that in 1986?
Offer a very short reply. 0.99. What is the ratio of the Production index(2004-2006) of Tanzania in 1985 to that in 1986?
Your response must be concise. 0.98. What is the ratio of the Production index(2004-2006) of Bulgaria in 1985 to that in 1987?
Provide a short and direct response. 0.96. What is the ratio of the Production index(2004-2006) in Guyana in 1985 to that in 1987?
Your answer should be very brief. 1.05. What is the ratio of the Production index(2004-2006) in Malta in 1985 to that in 1987?
Give a very brief answer. 0.98. What is the ratio of the Production index(2004-2006) of Tanzania in 1985 to that in 1987?
Your answer should be compact. 0.98. What is the ratio of the Production index(2004-2006) of Bulgaria in 1985 to that in 1988?
Provide a short and direct response. 0.96. What is the ratio of the Production index(2004-2006) of Guyana in 1985 to that in 1988?
Your response must be concise. 1.12. What is the ratio of the Production index(2004-2006) of Malta in 1985 to that in 1988?
Ensure brevity in your answer.  0.97. What is the ratio of the Production index(2004-2006) in Bulgaria in 1986 to that in 1987?
Ensure brevity in your answer.  1.05. What is the ratio of the Production index(2004-2006) of Guyana in 1986 to that in 1987?
Offer a very short reply. 1.09. What is the ratio of the Production index(2004-2006) of Tanzania in 1986 to that in 1987?
Offer a terse response. 1. What is the ratio of the Production index(2004-2006) in Bulgaria in 1986 to that in 1988?
Your response must be concise. 1.05. What is the ratio of the Production index(2004-2006) in Guyana in 1986 to that in 1988?
Give a very brief answer. 1.17. What is the ratio of the Production index(2004-2006) in Malta in 1986 to that in 1988?
Provide a succinct answer. 0.98. What is the ratio of the Production index(2004-2006) of Tanzania in 1986 to that in 1988?
Your response must be concise. 1.01. What is the ratio of the Production index(2004-2006) of Bulgaria in 1987 to that in 1988?
Make the answer very short. 1. What is the ratio of the Production index(2004-2006) of Guyana in 1987 to that in 1988?
Ensure brevity in your answer.  1.07. What is the ratio of the Production index(2004-2006) in Malta in 1987 to that in 1988?
Ensure brevity in your answer.  0.99. What is the difference between the highest and the second highest Production index(2004-2006) of Bulgaria?
Provide a succinct answer. 2.03. What is the difference between the highest and the second highest Production index(2004-2006) of Guyana?
Provide a succinct answer. 1.31. What is the difference between the highest and the second highest Production index(2004-2006) of Malta?
Ensure brevity in your answer.  1.12. What is the difference between the highest and the second highest Production index(2004-2006) in Tanzania?
Keep it short and to the point. 0.26. What is the difference between the highest and the lowest Production index(2004-2006) of Bulgaria?
Keep it short and to the point. 27.19. What is the difference between the highest and the lowest Production index(2004-2006) of Guyana?
Keep it short and to the point. 17.94. What is the difference between the highest and the lowest Production index(2004-2006) in Malta?
Offer a terse response. 14.27. What is the difference between the highest and the lowest Production index(2004-2006) in Tanzania?
Ensure brevity in your answer.  10.92. 